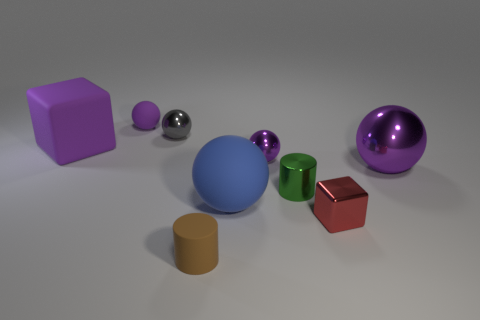The big object that is on the right side of the tiny shiny cylinder has what shape?
Ensure brevity in your answer.  Sphere. The matte ball right of the tiny object on the left side of the small gray shiny object is what color?
Give a very brief answer. Blue. What is the color of the other object that is the same shape as the tiny brown rubber object?
Ensure brevity in your answer.  Green. How many large metallic things have the same color as the large cube?
Provide a succinct answer. 1. There is a matte cylinder; is its color the same as the tiny shiny sphere to the right of the small brown object?
Ensure brevity in your answer.  No. There is a purple thing that is both to the right of the purple matte cube and to the left of the blue rubber thing; what shape is it?
Your answer should be very brief. Sphere. There is a purple sphere left of the tiny metallic object that is on the left side of the large object in front of the large purple metallic ball; what is it made of?
Your response must be concise. Rubber. Is the number of large metallic spheres that are behind the gray metallic ball greater than the number of small purple metal objects in front of the rubber cylinder?
Offer a very short reply. No. How many small brown objects have the same material as the brown cylinder?
Provide a succinct answer. 0. Does the purple object that is behind the tiny gray thing have the same shape as the rubber object in front of the red metal block?
Your answer should be compact. No. 